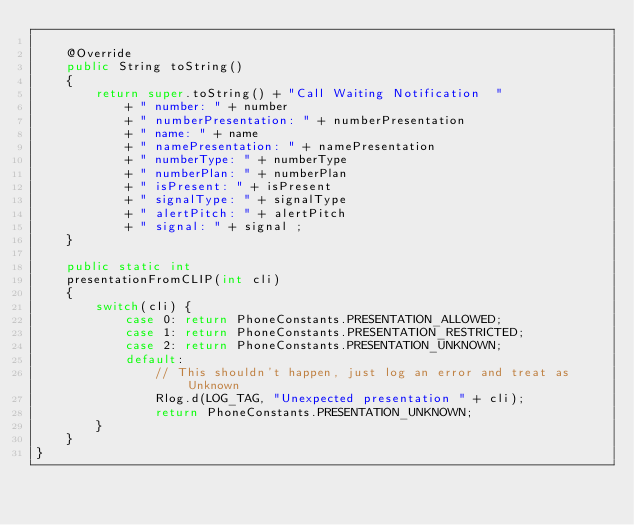<code> <loc_0><loc_0><loc_500><loc_500><_Java_>
    @Override
    public String toString()
    {
        return super.toString() + "Call Waiting Notification  "
            + " number: " + number
            + " numberPresentation: " + numberPresentation
            + " name: " + name
            + " namePresentation: " + namePresentation
            + " numberType: " + numberType
            + " numberPlan: " + numberPlan
            + " isPresent: " + isPresent
            + " signalType: " + signalType
            + " alertPitch: " + alertPitch
            + " signal: " + signal ;
    }

    public static int
    presentationFromCLIP(int cli)
    {
        switch(cli) {
            case 0: return PhoneConstants.PRESENTATION_ALLOWED;
            case 1: return PhoneConstants.PRESENTATION_RESTRICTED;
            case 2: return PhoneConstants.PRESENTATION_UNKNOWN;
            default:
                // This shouldn't happen, just log an error and treat as Unknown
                Rlog.d(LOG_TAG, "Unexpected presentation " + cli);
                return PhoneConstants.PRESENTATION_UNKNOWN;
        }
    }
}
</code> 